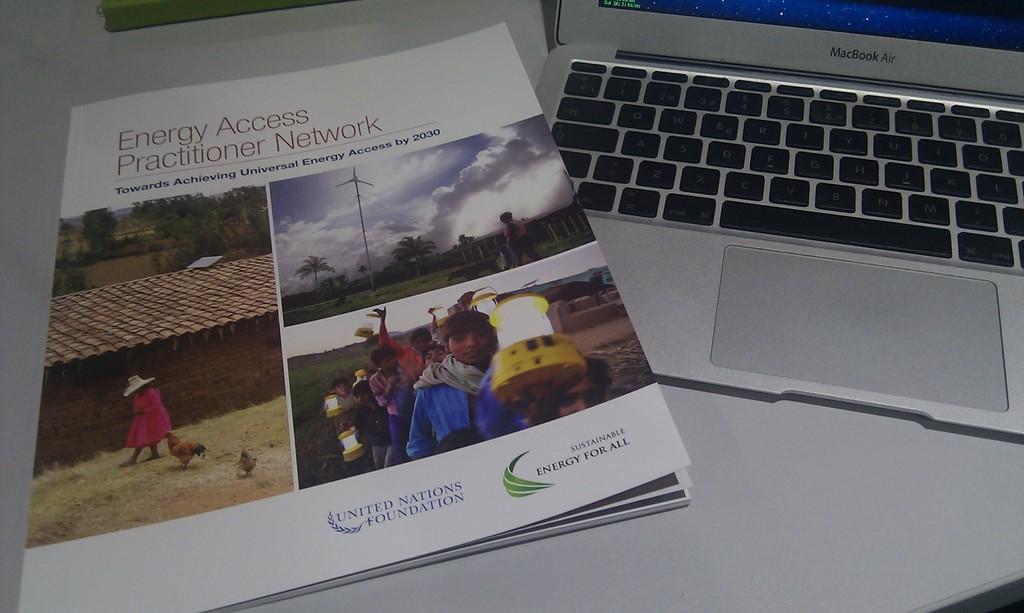What brand of mac?
Make the answer very short. Macbook air. 